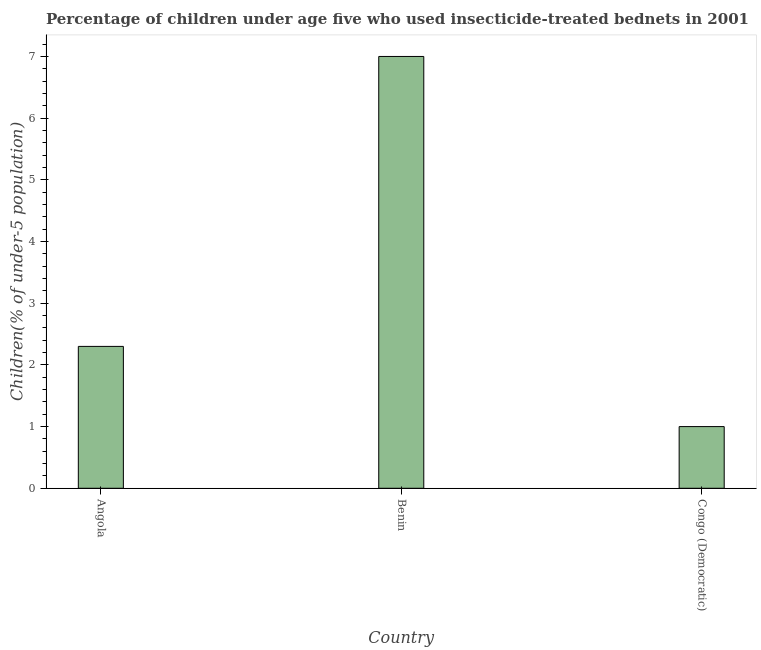Does the graph contain any zero values?
Offer a very short reply. No. What is the title of the graph?
Your answer should be very brief. Percentage of children under age five who used insecticide-treated bednets in 2001. What is the label or title of the Y-axis?
Your response must be concise. Children(% of under-5 population). Across all countries, what is the minimum percentage of children who use of insecticide-treated bed nets?
Your answer should be very brief. 1. In which country was the percentage of children who use of insecticide-treated bed nets maximum?
Your response must be concise. Benin. In which country was the percentage of children who use of insecticide-treated bed nets minimum?
Your response must be concise. Congo (Democratic). What is the sum of the percentage of children who use of insecticide-treated bed nets?
Offer a very short reply. 10.3. What is the average percentage of children who use of insecticide-treated bed nets per country?
Your response must be concise. 3.43. What is the median percentage of children who use of insecticide-treated bed nets?
Keep it short and to the point. 2.3. In how many countries, is the percentage of children who use of insecticide-treated bed nets greater than 3.2 %?
Offer a very short reply. 1. Is the difference between the percentage of children who use of insecticide-treated bed nets in Angola and Benin greater than the difference between any two countries?
Offer a very short reply. No. Is the sum of the percentage of children who use of insecticide-treated bed nets in Angola and Congo (Democratic) greater than the maximum percentage of children who use of insecticide-treated bed nets across all countries?
Provide a succinct answer. No. In how many countries, is the percentage of children who use of insecticide-treated bed nets greater than the average percentage of children who use of insecticide-treated bed nets taken over all countries?
Your response must be concise. 1. How many bars are there?
Ensure brevity in your answer.  3. How many countries are there in the graph?
Your answer should be compact. 3. What is the difference between two consecutive major ticks on the Y-axis?
Ensure brevity in your answer.  1. What is the Children(% of under-5 population) in Angola?
Give a very brief answer. 2.3. What is the Children(% of under-5 population) of Benin?
Your response must be concise. 7. What is the difference between the Children(% of under-5 population) in Angola and Benin?
Make the answer very short. -4.7. What is the difference between the Children(% of under-5 population) in Angola and Congo (Democratic)?
Keep it short and to the point. 1.3. What is the difference between the Children(% of under-5 population) in Benin and Congo (Democratic)?
Your answer should be compact. 6. What is the ratio of the Children(% of under-5 population) in Angola to that in Benin?
Keep it short and to the point. 0.33. 